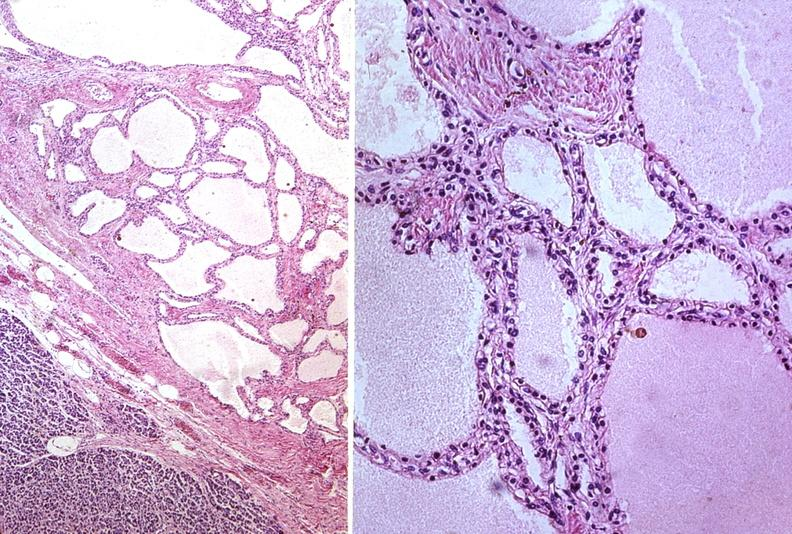does premature coronary disease show cystadenoma?
Answer the question using a single word or phrase. No 